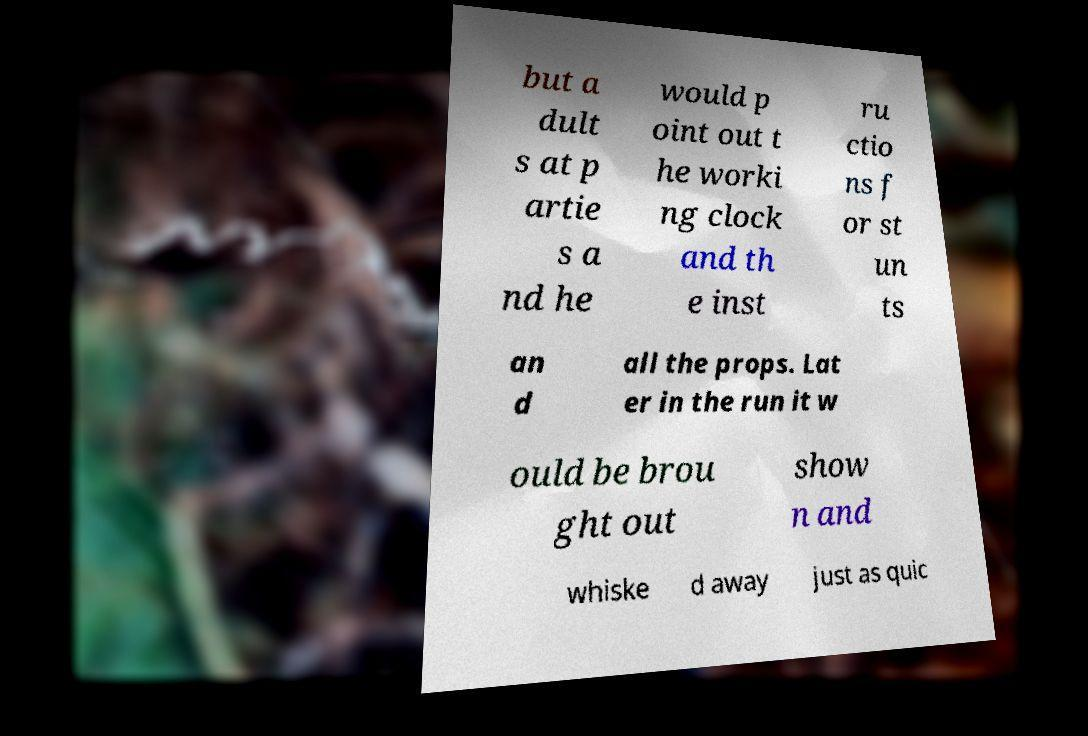Please read and relay the text visible in this image. What does it say? but a dult s at p artie s a nd he would p oint out t he worki ng clock and th e inst ru ctio ns f or st un ts an d all the props. Lat er in the run it w ould be brou ght out show n and whiske d away just as quic 